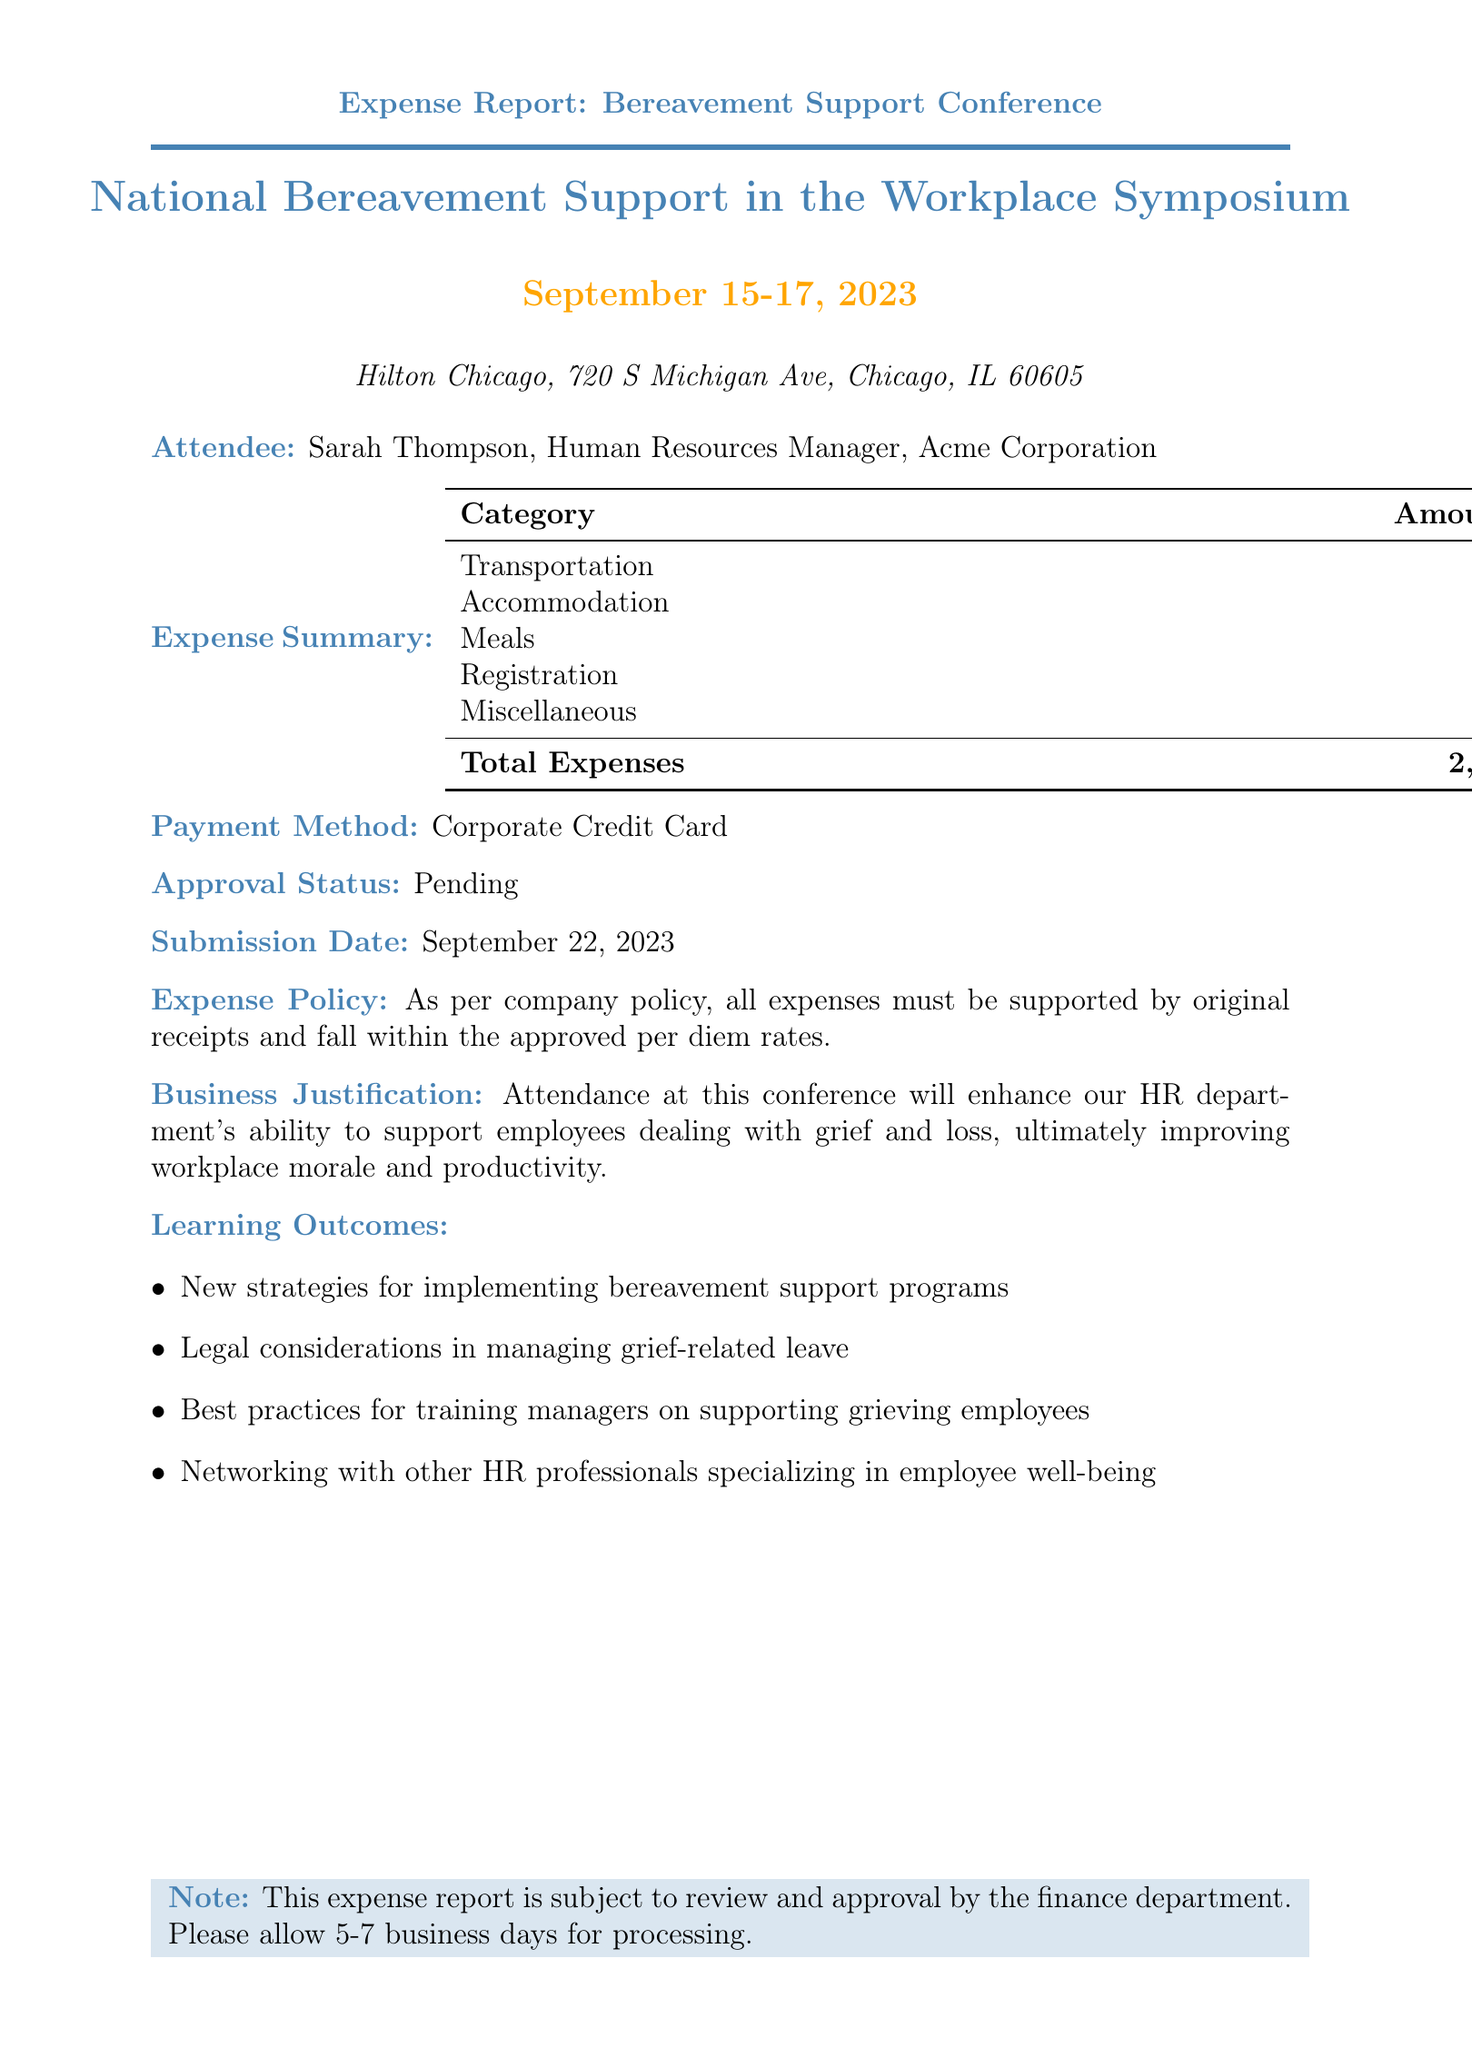What is the conference name? The conference name is stated at the beginning of the document as "National Bereavement Support in the Workplace Symposium."
Answer: National Bereavement Support in the Workplace Symposium What are the total expenses? The total expenses are summarized in the document, which lists the total amount incurred for the conference as $2,227.89.
Answer: 2,227.89 Who is the attendee? The attendee's name and position are mentioned in the document as Sarah Thompson, Human Resources Manager.
Answer: Sarah Thompson What is the date of the conference? The date of the conference is explicitly mentioned in the document as September 15-17, 2023.
Answer: September 15-17, 2023 What is the payment method used for the expenses? The payment method is listed in the document, indicating that a Corporate Credit Card was used.
Answer: Corporate Credit Card What are the learning outcomes from the conference? The document provides a list of learning outcomes that are meant to enhance HR capabilities in supporting grieving employees, including networking and strategies for bereavement support programs.
Answer: New strategies for implementing bereavement support programs What is the business justification for attending the conference? The document includes a statement explaining that attending the conference will improve the HR department’s ability to support grieving employees and ultimately improve morale and productivity.
Answer: Attendance at this conference will enhance our HR department's ability to support employees dealing with grief and loss What is the approval status of the expense report? The document states the approval status, showing that it is currently pending review.
Answer: Pending 